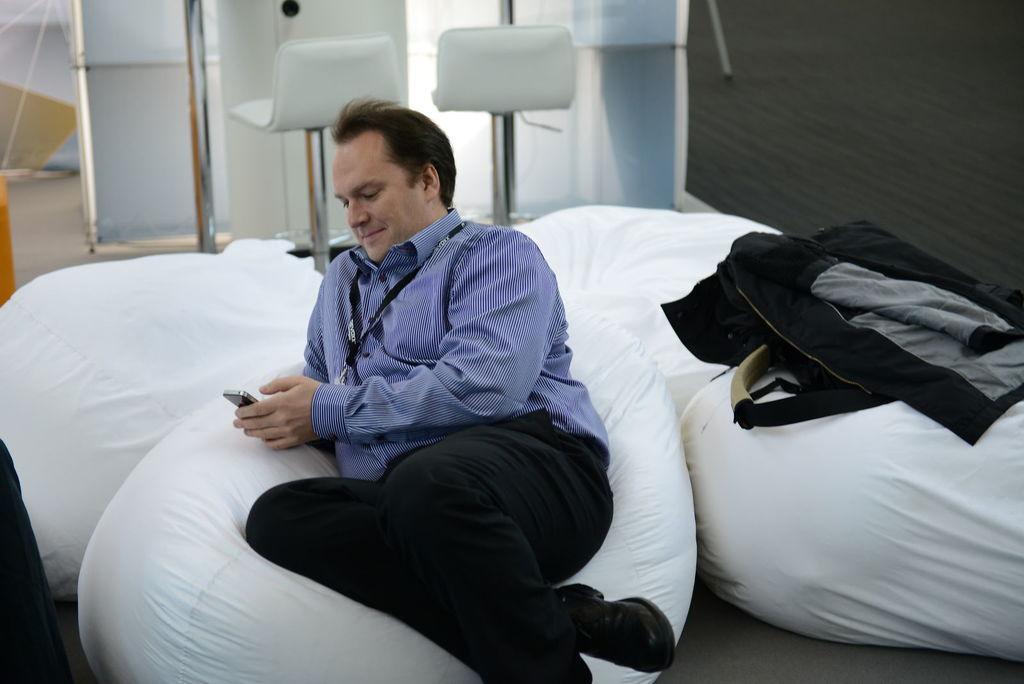Describe this image in one or two sentences. In this image we can see this person wearing shirt and identity card is sitting on the white color bean bag and holding a mobile phone in his hands. Here we can see a jacket and backpack are kept on the white color bean bag. The background of the image is slightly blurred, where we can see chairs and the wall. 